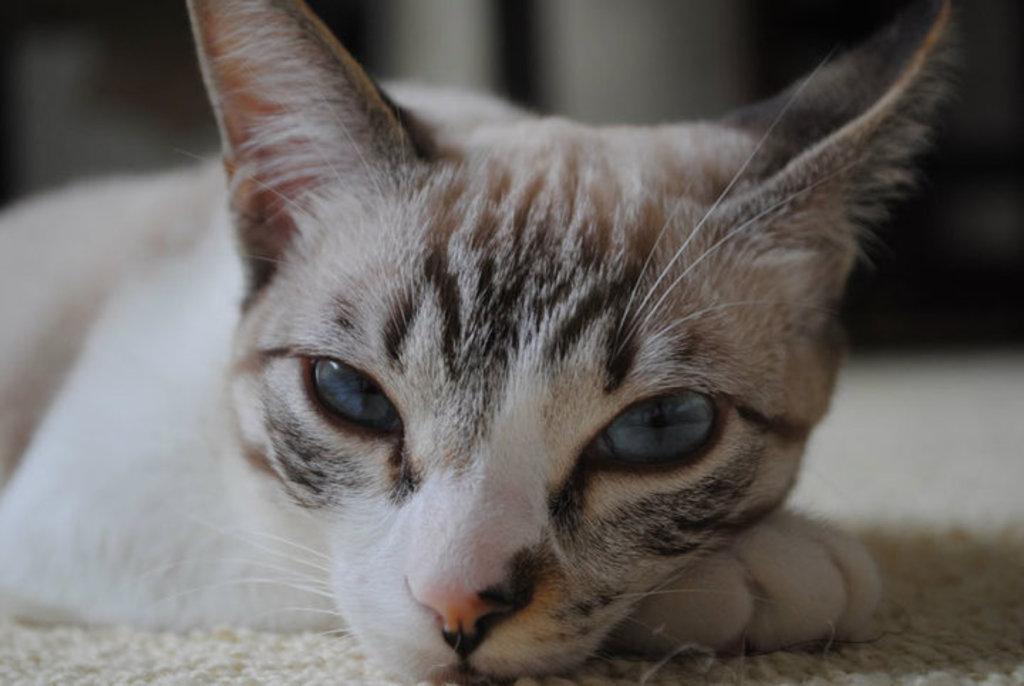In one or two sentences, can you explain what this image depicts? In this image we can see a cat on a mat. 